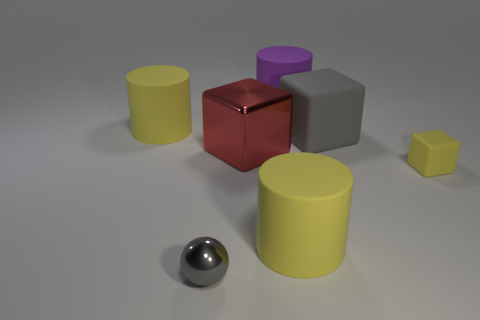Which object seems out of place compared to the others? The sphere appears somewhat out of place as all other objects are some form of polyhedron, mostly cubes and cylinders.  How does lighting affect the colors of the objects? The lighting seems to be coming from above, creating subtle shadows and giving the objects a soft appearance. It especially highlights the metallic sheen of the red cube and the sphere. 